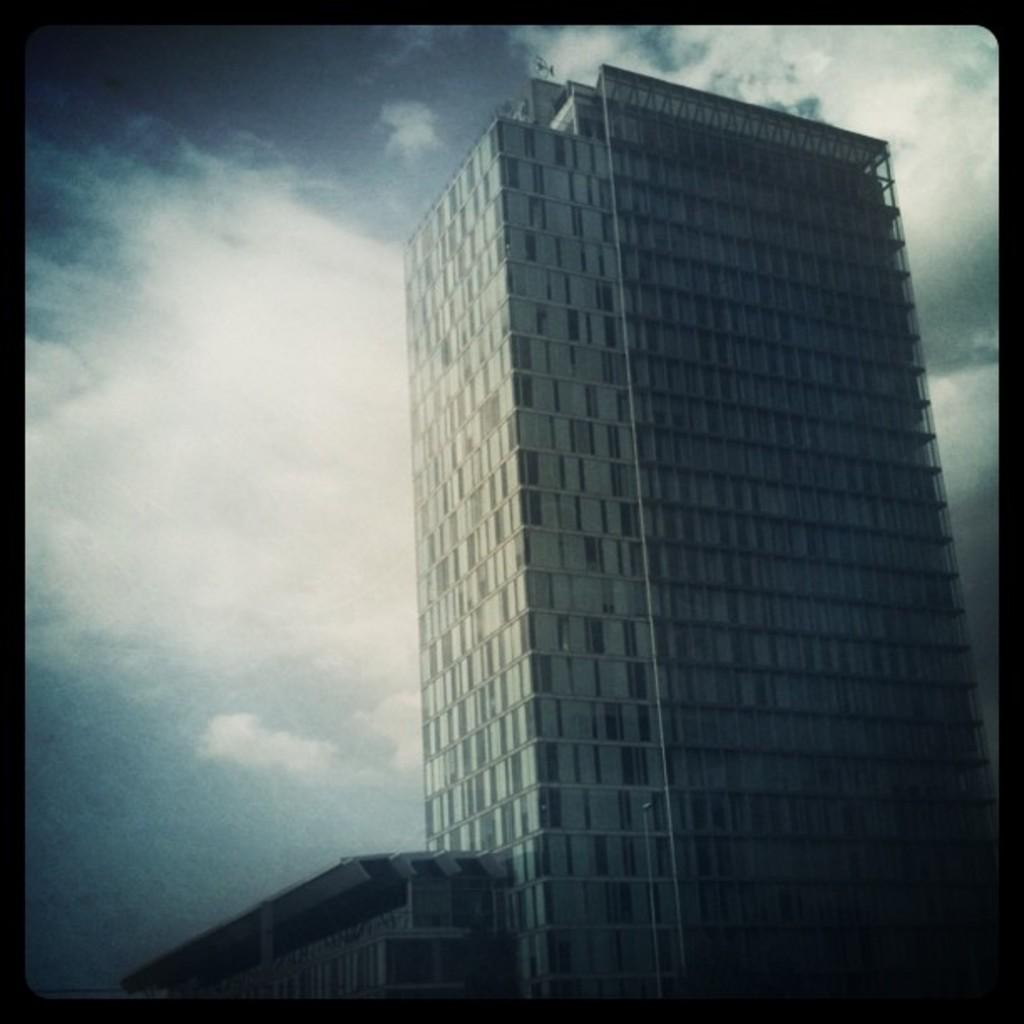What type of structure is present in the image? There is a building in the image. Can you describe the color of the building? The building is white in color. What can be seen in the background of the image? The sky is visible in the background of the image. How would you describe the color of the sky in the image? The sky is white and gray in color. What type of attraction is present in the image? There is no attraction mentioned or visible in the image; it only features a white building and a white and gray sky. 